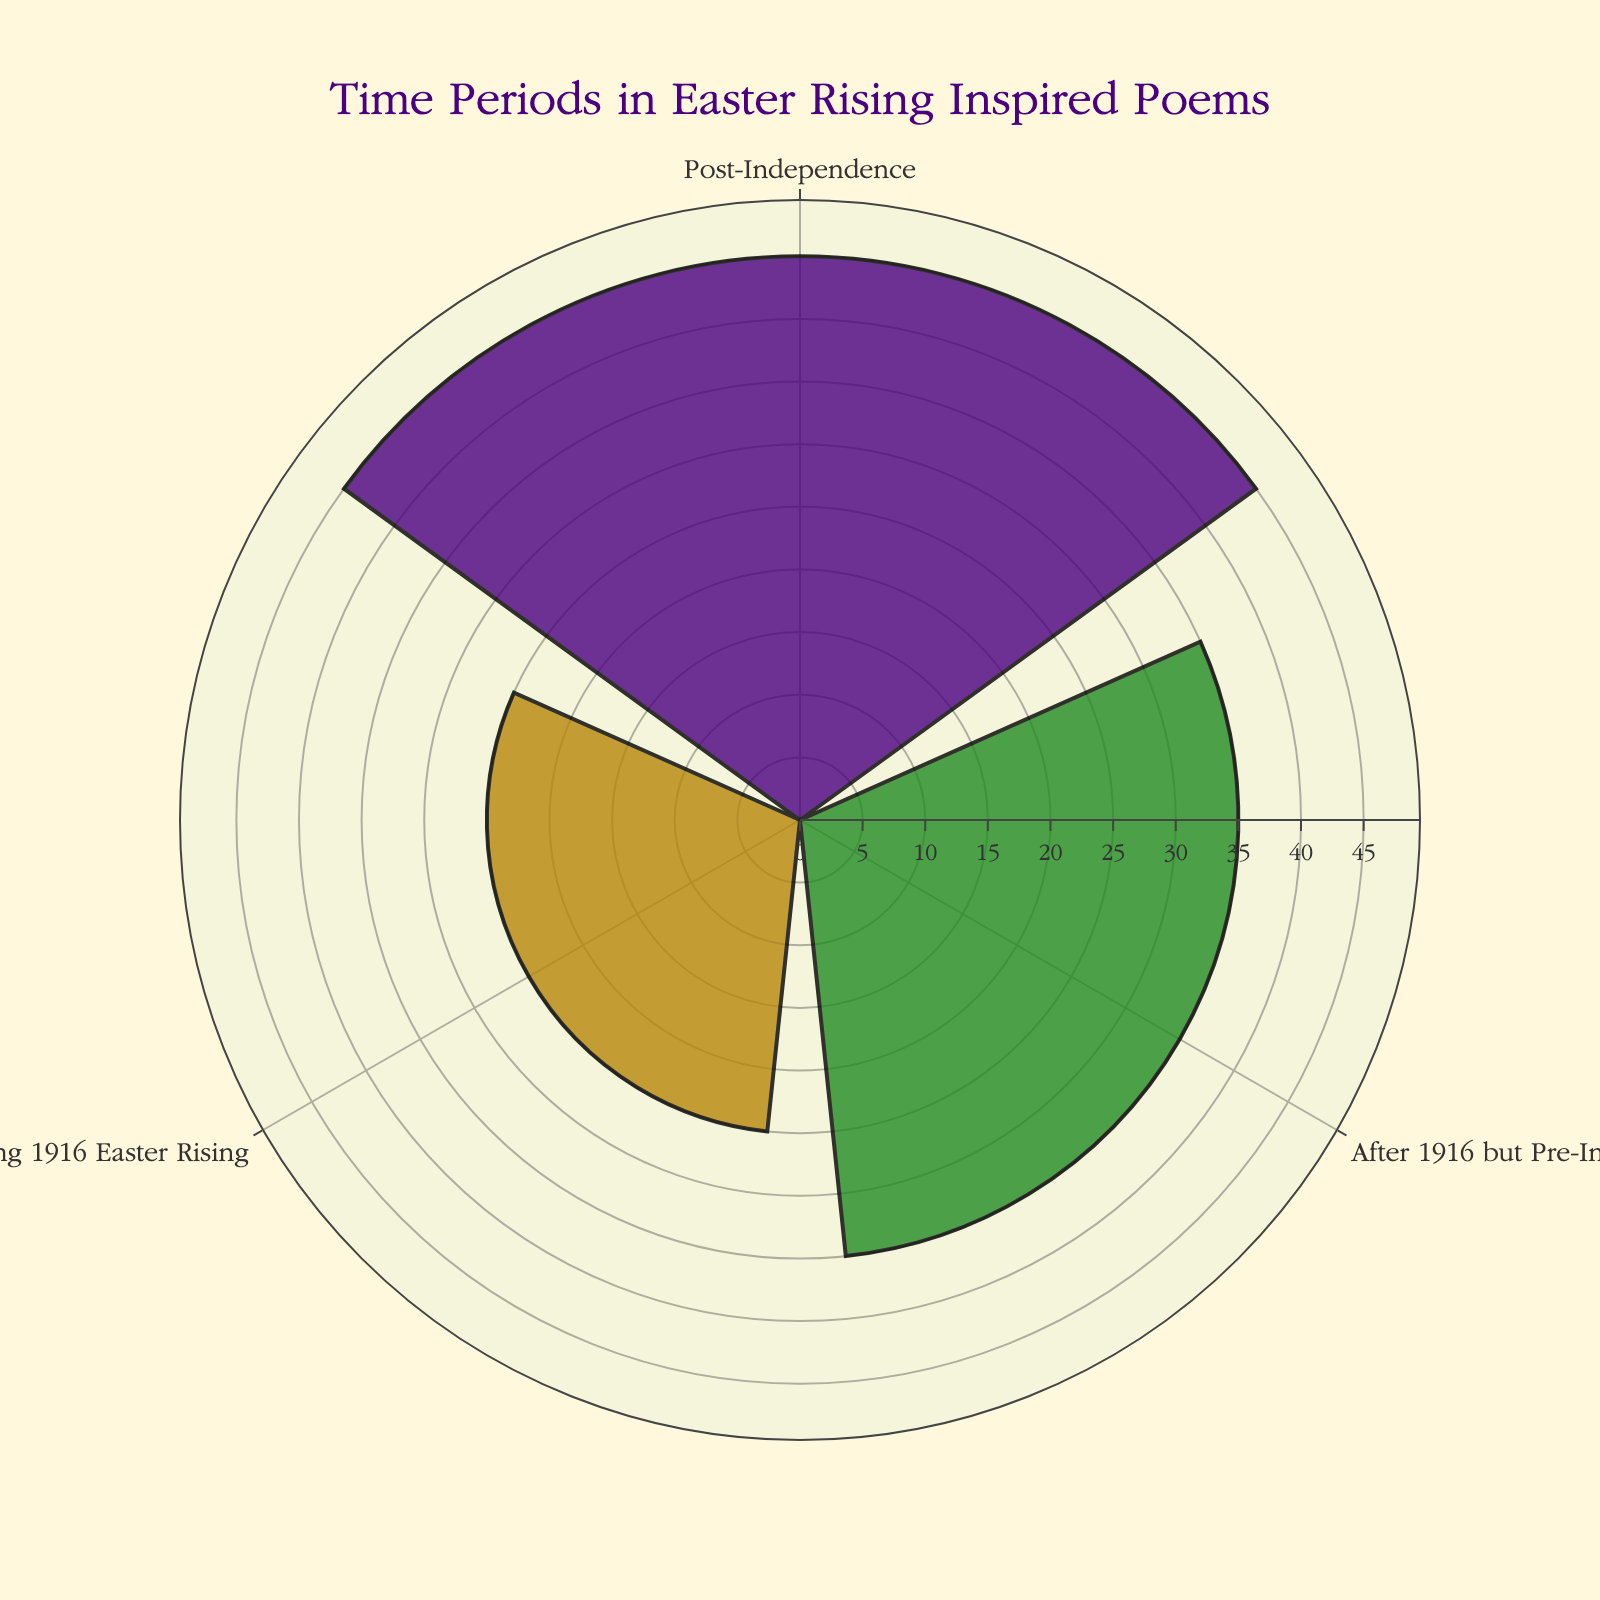What is the title of the figure? The title is displayed at the top of the chart in a distinct font and color, making it easy to identify.
Answer: Time Periods in Easter Rising Inspired Poems How many time periods are shown in the figure? The figure shows three categories for time periods. This can be counted by looking at the number of different labels on the chart.
Answer: 3 Which time period has the highest count of poems? To determine the highest count, compare the lengths of the bars. The longest bar represents the time period with the highest count.
Answer: Post-Independence Which categories are included in the figure? The categories are indicated as the labels around the chart. The figure shows the top three categories according to poem count.
Answer: During 1916 Easter Rising, After 1916 but Pre-Independence, Post-Independence What is the total count of poems for the top three time periods? Add the counts of the three displayed categories: Post-Independence (45), After 1916 but Pre-Independence (35), and During 1916 Easter Rising (25). The sum will be the total.
Answer: 105 Which category has the lowest count among the displayed ones? Identify the category with the shortest bar to find the one with the lowest count.
Answer: During 1916 Easter Rising What is the difference in poem count between 'After 1916 but Pre-Independence' and 'During 1916 Easter Rising'? Subtract the count of 'During 1916 Easter Rising' (25) from 'After 1916 but Pre-Independence' (35).
Answer: 10 What is the average poem count for the displayed categories? To find the average, sum the counts of the three categories (45, 35, 25) and divide by 3. \(\frac{45+35+25}{3} = \frac{105}{3} = 35\)
Answer: 35 In which direction is the angular axis of the chart rotating? This information is derived from observing the layout of the angular axis and is specified in the plot description.
Answer: Clockwise 